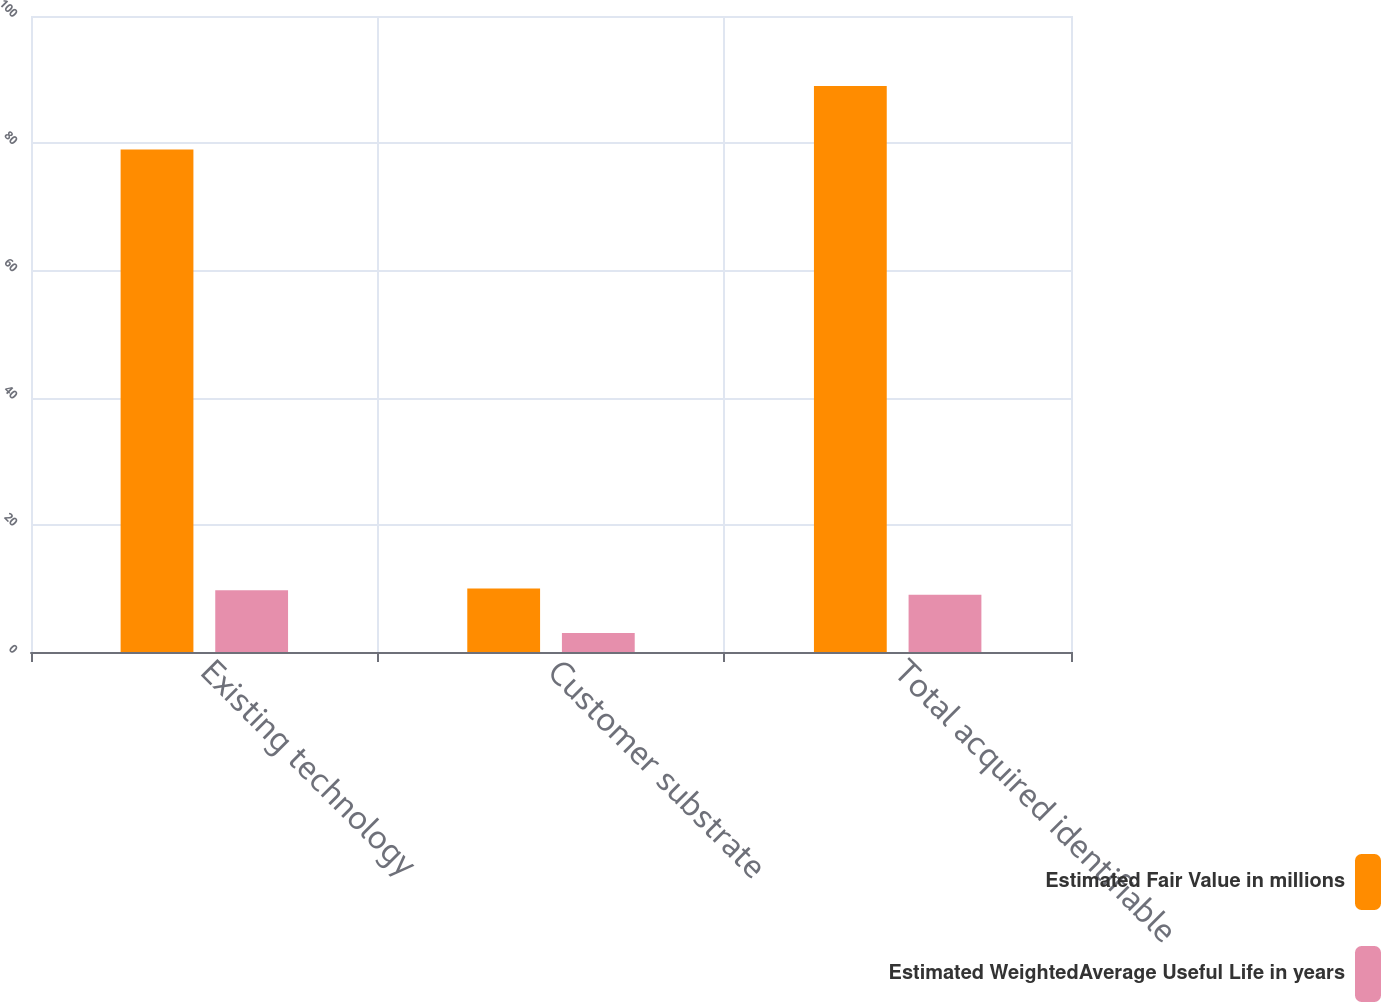<chart> <loc_0><loc_0><loc_500><loc_500><stacked_bar_chart><ecel><fcel>Existing technology<fcel>Customer substrate<fcel>Total acquired identifiable<nl><fcel>Estimated Fair Value in millions<fcel>79<fcel>10<fcel>89<nl><fcel>Estimated WeightedAverage Useful Life in years<fcel>9.7<fcel>3<fcel>9<nl></chart> 